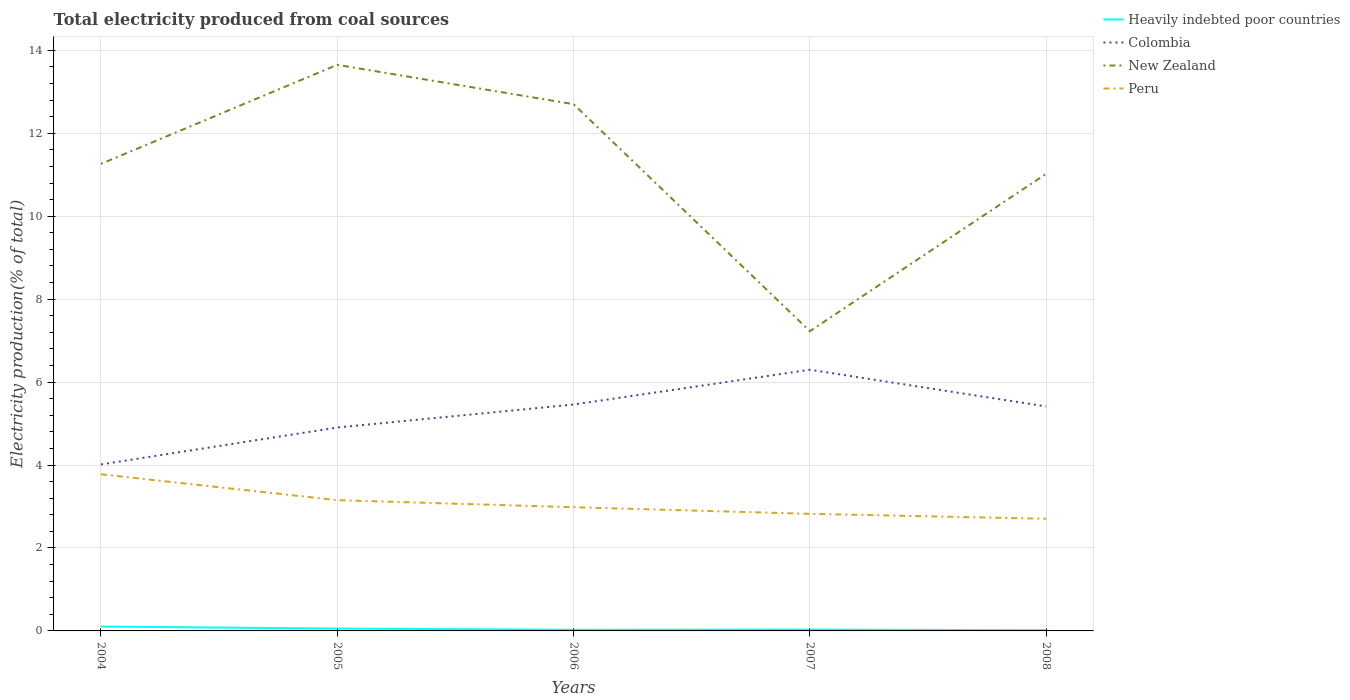Is the number of lines equal to the number of legend labels?
Offer a very short reply. Yes. Across all years, what is the maximum total electricity produced in Heavily indebted poor countries?
Keep it short and to the point. 0.02. What is the total total electricity produced in New Zealand in the graph?
Your answer should be very brief. -3.79. What is the difference between the highest and the second highest total electricity produced in Peru?
Keep it short and to the point. 1.07. Is the total electricity produced in Heavily indebted poor countries strictly greater than the total electricity produced in Colombia over the years?
Ensure brevity in your answer.  Yes. How many lines are there?
Your response must be concise. 4. Are the values on the major ticks of Y-axis written in scientific E-notation?
Your answer should be compact. No. Does the graph contain grids?
Provide a succinct answer. Yes. How many legend labels are there?
Keep it short and to the point. 4. What is the title of the graph?
Ensure brevity in your answer.  Total electricity produced from coal sources. What is the label or title of the X-axis?
Provide a succinct answer. Years. What is the Electricity production(% of total) in Heavily indebted poor countries in 2004?
Your answer should be compact. 0.11. What is the Electricity production(% of total) of Colombia in 2004?
Provide a succinct answer. 4.01. What is the Electricity production(% of total) in New Zealand in 2004?
Provide a succinct answer. 11.26. What is the Electricity production(% of total) of Peru in 2004?
Keep it short and to the point. 3.78. What is the Electricity production(% of total) in Heavily indebted poor countries in 2005?
Ensure brevity in your answer.  0.06. What is the Electricity production(% of total) of Colombia in 2005?
Your answer should be compact. 4.9. What is the Electricity production(% of total) in New Zealand in 2005?
Offer a very short reply. 13.65. What is the Electricity production(% of total) of Peru in 2005?
Provide a short and direct response. 3.15. What is the Electricity production(% of total) in Heavily indebted poor countries in 2006?
Your answer should be very brief. 0.03. What is the Electricity production(% of total) in Colombia in 2006?
Offer a terse response. 5.46. What is the Electricity production(% of total) of New Zealand in 2006?
Make the answer very short. 12.7. What is the Electricity production(% of total) in Peru in 2006?
Offer a terse response. 2.98. What is the Electricity production(% of total) in Heavily indebted poor countries in 2007?
Your answer should be compact. 0.03. What is the Electricity production(% of total) of Colombia in 2007?
Provide a short and direct response. 6.3. What is the Electricity production(% of total) in New Zealand in 2007?
Your answer should be very brief. 7.23. What is the Electricity production(% of total) in Peru in 2007?
Make the answer very short. 2.82. What is the Electricity production(% of total) in Heavily indebted poor countries in 2008?
Offer a very short reply. 0.02. What is the Electricity production(% of total) in Colombia in 2008?
Your answer should be compact. 5.41. What is the Electricity production(% of total) of New Zealand in 2008?
Keep it short and to the point. 11.02. What is the Electricity production(% of total) in Peru in 2008?
Make the answer very short. 2.7. Across all years, what is the maximum Electricity production(% of total) of Heavily indebted poor countries?
Provide a succinct answer. 0.11. Across all years, what is the maximum Electricity production(% of total) in Colombia?
Offer a very short reply. 6.3. Across all years, what is the maximum Electricity production(% of total) of New Zealand?
Keep it short and to the point. 13.65. Across all years, what is the maximum Electricity production(% of total) in Peru?
Provide a succinct answer. 3.78. Across all years, what is the minimum Electricity production(% of total) in Heavily indebted poor countries?
Make the answer very short. 0.02. Across all years, what is the minimum Electricity production(% of total) of Colombia?
Provide a short and direct response. 4.01. Across all years, what is the minimum Electricity production(% of total) of New Zealand?
Offer a terse response. 7.23. Across all years, what is the minimum Electricity production(% of total) in Peru?
Offer a very short reply. 2.7. What is the total Electricity production(% of total) of Heavily indebted poor countries in the graph?
Keep it short and to the point. 0.24. What is the total Electricity production(% of total) of Colombia in the graph?
Your answer should be compact. 26.09. What is the total Electricity production(% of total) of New Zealand in the graph?
Provide a succinct answer. 55.86. What is the total Electricity production(% of total) of Peru in the graph?
Provide a succinct answer. 15.44. What is the difference between the Electricity production(% of total) of Heavily indebted poor countries in 2004 and that in 2005?
Give a very brief answer. 0.05. What is the difference between the Electricity production(% of total) of Colombia in 2004 and that in 2005?
Give a very brief answer. -0.89. What is the difference between the Electricity production(% of total) of New Zealand in 2004 and that in 2005?
Provide a succinct answer. -2.39. What is the difference between the Electricity production(% of total) in Peru in 2004 and that in 2005?
Keep it short and to the point. 0.62. What is the difference between the Electricity production(% of total) in Heavily indebted poor countries in 2004 and that in 2006?
Your answer should be very brief. 0.08. What is the difference between the Electricity production(% of total) in Colombia in 2004 and that in 2006?
Provide a succinct answer. -1.44. What is the difference between the Electricity production(% of total) in New Zealand in 2004 and that in 2006?
Your answer should be very brief. -1.44. What is the difference between the Electricity production(% of total) in Peru in 2004 and that in 2006?
Provide a short and direct response. 0.79. What is the difference between the Electricity production(% of total) in Heavily indebted poor countries in 2004 and that in 2007?
Your response must be concise. 0.07. What is the difference between the Electricity production(% of total) in Colombia in 2004 and that in 2007?
Your answer should be very brief. -2.28. What is the difference between the Electricity production(% of total) of New Zealand in 2004 and that in 2007?
Provide a succinct answer. 4.03. What is the difference between the Electricity production(% of total) in Peru in 2004 and that in 2007?
Give a very brief answer. 0.95. What is the difference between the Electricity production(% of total) of Heavily indebted poor countries in 2004 and that in 2008?
Offer a terse response. 0.09. What is the difference between the Electricity production(% of total) of Colombia in 2004 and that in 2008?
Your response must be concise. -1.4. What is the difference between the Electricity production(% of total) in New Zealand in 2004 and that in 2008?
Ensure brevity in your answer.  0.24. What is the difference between the Electricity production(% of total) of Peru in 2004 and that in 2008?
Your answer should be very brief. 1.07. What is the difference between the Electricity production(% of total) of Heavily indebted poor countries in 2005 and that in 2006?
Your answer should be compact. 0.03. What is the difference between the Electricity production(% of total) in Colombia in 2005 and that in 2006?
Your answer should be very brief. -0.55. What is the difference between the Electricity production(% of total) in New Zealand in 2005 and that in 2006?
Keep it short and to the point. 0.95. What is the difference between the Electricity production(% of total) of Peru in 2005 and that in 2006?
Make the answer very short. 0.17. What is the difference between the Electricity production(% of total) of Heavily indebted poor countries in 2005 and that in 2007?
Provide a succinct answer. 0.02. What is the difference between the Electricity production(% of total) in Colombia in 2005 and that in 2007?
Your response must be concise. -1.39. What is the difference between the Electricity production(% of total) of New Zealand in 2005 and that in 2007?
Offer a very short reply. 6.42. What is the difference between the Electricity production(% of total) in Peru in 2005 and that in 2007?
Offer a very short reply. 0.33. What is the difference between the Electricity production(% of total) in Heavily indebted poor countries in 2005 and that in 2008?
Provide a succinct answer. 0.04. What is the difference between the Electricity production(% of total) in Colombia in 2005 and that in 2008?
Give a very brief answer. -0.51. What is the difference between the Electricity production(% of total) of New Zealand in 2005 and that in 2008?
Ensure brevity in your answer.  2.63. What is the difference between the Electricity production(% of total) in Peru in 2005 and that in 2008?
Your answer should be compact. 0.45. What is the difference between the Electricity production(% of total) in Heavily indebted poor countries in 2006 and that in 2007?
Give a very brief answer. -0. What is the difference between the Electricity production(% of total) in Colombia in 2006 and that in 2007?
Ensure brevity in your answer.  -0.84. What is the difference between the Electricity production(% of total) in New Zealand in 2006 and that in 2007?
Your answer should be compact. 5.47. What is the difference between the Electricity production(% of total) of Peru in 2006 and that in 2007?
Your response must be concise. 0.16. What is the difference between the Electricity production(% of total) of Heavily indebted poor countries in 2006 and that in 2008?
Provide a succinct answer. 0.01. What is the difference between the Electricity production(% of total) in Colombia in 2006 and that in 2008?
Give a very brief answer. 0.05. What is the difference between the Electricity production(% of total) in New Zealand in 2006 and that in 2008?
Offer a terse response. 1.68. What is the difference between the Electricity production(% of total) of Peru in 2006 and that in 2008?
Provide a succinct answer. 0.28. What is the difference between the Electricity production(% of total) in Heavily indebted poor countries in 2007 and that in 2008?
Make the answer very short. 0.02. What is the difference between the Electricity production(% of total) in Colombia in 2007 and that in 2008?
Offer a very short reply. 0.88. What is the difference between the Electricity production(% of total) of New Zealand in 2007 and that in 2008?
Your answer should be very brief. -3.79. What is the difference between the Electricity production(% of total) of Peru in 2007 and that in 2008?
Keep it short and to the point. 0.12. What is the difference between the Electricity production(% of total) in Heavily indebted poor countries in 2004 and the Electricity production(% of total) in Colombia in 2005?
Offer a very short reply. -4.8. What is the difference between the Electricity production(% of total) of Heavily indebted poor countries in 2004 and the Electricity production(% of total) of New Zealand in 2005?
Give a very brief answer. -13.54. What is the difference between the Electricity production(% of total) in Heavily indebted poor countries in 2004 and the Electricity production(% of total) in Peru in 2005?
Offer a terse response. -3.05. What is the difference between the Electricity production(% of total) of Colombia in 2004 and the Electricity production(% of total) of New Zealand in 2005?
Your answer should be very brief. -9.64. What is the difference between the Electricity production(% of total) in Colombia in 2004 and the Electricity production(% of total) in Peru in 2005?
Ensure brevity in your answer.  0.86. What is the difference between the Electricity production(% of total) of New Zealand in 2004 and the Electricity production(% of total) of Peru in 2005?
Give a very brief answer. 8.11. What is the difference between the Electricity production(% of total) in Heavily indebted poor countries in 2004 and the Electricity production(% of total) in Colombia in 2006?
Make the answer very short. -5.35. What is the difference between the Electricity production(% of total) in Heavily indebted poor countries in 2004 and the Electricity production(% of total) in New Zealand in 2006?
Offer a terse response. -12.6. What is the difference between the Electricity production(% of total) in Heavily indebted poor countries in 2004 and the Electricity production(% of total) in Peru in 2006?
Offer a terse response. -2.88. What is the difference between the Electricity production(% of total) of Colombia in 2004 and the Electricity production(% of total) of New Zealand in 2006?
Provide a short and direct response. -8.69. What is the difference between the Electricity production(% of total) in Colombia in 2004 and the Electricity production(% of total) in Peru in 2006?
Provide a succinct answer. 1.03. What is the difference between the Electricity production(% of total) in New Zealand in 2004 and the Electricity production(% of total) in Peru in 2006?
Offer a terse response. 8.28. What is the difference between the Electricity production(% of total) of Heavily indebted poor countries in 2004 and the Electricity production(% of total) of Colombia in 2007?
Your answer should be very brief. -6.19. What is the difference between the Electricity production(% of total) of Heavily indebted poor countries in 2004 and the Electricity production(% of total) of New Zealand in 2007?
Your response must be concise. -7.12. What is the difference between the Electricity production(% of total) in Heavily indebted poor countries in 2004 and the Electricity production(% of total) in Peru in 2007?
Make the answer very short. -2.72. What is the difference between the Electricity production(% of total) in Colombia in 2004 and the Electricity production(% of total) in New Zealand in 2007?
Give a very brief answer. -3.21. What is the difference between the Electricity production(% of total) in Colombia in 2004 and the Electricity production(% of total) in Peru in 2007?
Make the answer very short. 1.19. What is the difference between the Electricity production(% of total) of New Zealand in 2004 and the Electricity production(% of total) of Peru in 2007?
Ensure brevity in your answer.  8.44. What is the difference between the Electricity production(% of total) in Heavily indebted poor countries in 2004 and the Electricity production(% of total) in Colombia in 2008?
Make the answer very short. -5.31. What is the difference between the Electricity production(% of total) of Heavily indebted poor countries in 2004 and the Electricity production(% of total) of New Zealand in 2008?
Your answer should be compact. -10.92. What is the difference between the Electricity production(% of total) of Heavily indebted poor countries in 2004 and the Electricity production(% of total) of Peru in 2008?
Offer a terse response. -2.6. What is the difference between the Electricity production(% of total) in Colombia in 2004 and the Electricity production(% of total) in New Zealand in 2008?
Make the answer very short. -7.01. What is the difference between the Electricity production(% of total) of Colombia in 2004 and the Electricity production(% of total) of Peru in 2008?
Offer a terse response. 1.31. What is the difference between the Electricity production(% of total) of New Zealand in 2004 and the Electricity production(% of total) of Peru in 2008?
Your answer should be compact. 8.56. What is the difference between the Electricity production(% of total) of Heavily indebted poor countries in 2005 and the Electricity production(% of total) of Colombia in 2006?
Keep it short and to the point. -5.4. What is the difference between the Electricity production(% of total) of Heavily indebted poor countries in 2005 and the Electricity production(% of total) of New Zealand in 2006?
Make the answer very short. -12.64. What is the difference between the Electricity production(% of total) of Heavily indebted poor countries in 2005 and the Electricity production(% of total) of Peru in 2006?
Your response must be concise. -2.93. What is the difference between the Electricity production(% of total) in Colombia in 2005 and the Electricity production(% of total) in New Zealand in 2006?
Provide a short and direct response. -7.8. What is the difference between the Electricity production(% of total) in Colombia in 2005 and the Electricity production(% of total) in Peru in 2006?
Your response must be concise. 1.92. What is the difference between the Electricity production(% of total) in New Zealand in 2005 and the Electricity production(% of total) in Peru in 2006?
Offer a terse response. 10.67. What is the difference between the Electricity production(% of total) in Heavily indebted poor countries in 2005 and the Electricity production(% of total) in Colombia in 2007?
Give a very brief answer. -6.24. What is the difference between the Electricity production(% of total) of Heavily indebted poor countries in 2005 and the Electricity production(% of total) of New Zealand in 2007?
Provide a succinct answer. -7.17. What is the difference between the Electricity production(% of total) of Heavily indebted poor countries in 2005 and the Electricity production(% of total) of Peru in 2007?
Make the answer very short. -2.77. What is the difference between the Electricity production(% of total) in Colombia in 2005 and the Electricity production(% of total) in New Zealand in 2007?
Your answer should be compact. -2.32. What is the difference between the Electricity production(% of total) of Colombia in 2005 and the Electricity production(% of total) of Peru in 2007?
Your response must be concise. 2.08. What is the difference between the Electricity production(% of total) of New Zealand in 2005 and the Electricity production(% of total) of Peru in 2007?
Your answer should be compact. 10.83. What is the difference between the Electricity production(% of total) in Heavily indebted poor countries in 2005 and the Electricity production(% of total) in Colombia in 2008?
Provide a short and direct response. -5.36. What is the difference between the Electricity production(% of total) in Heavily indebted poor countries in 2005 and the Electricity production(% of total) in New Zealand in 2008?
Offer a terse response. -10.97. What is the difference between the Electricity production(% of total) in Heavily indebted poor countries in 2005 and the Electricity production(% of total) in Peru in 2008?
Your answer should be very brief. -2.65. What is the difference between the Electricity production(% of total) of Colombia in 2005 and the Electricity production(% of total) of New Zealand in 2008?
Give a very brief answer. -6.12. What is the difference between the Electricity production(% of total) of Colombia in 2005 and the Electricity production(% of total) of Peru in 2008?
Offer a terse response. 2.2. What is the difference between the Electricity production(% of total) in New Zealand in 2005 and the Electricity production(% of total) in Peru in 2008?
Provide a short and direct response. 10.95. What is the difference between the Electricity production(% of total) in Heavily indebted poor countries in 2006 and the Electricity production(% of total) in Colombia in 2007?
Give a very brief answer. -6.27. What is the difference between the Electricity production(% of total) of Heavily indebted poor countries in 2006 and the Electricity production(% of total) of New Zealand in 2007?
Your response must be concise. -7.2. What is the difference between the Electricity production(% of total) of Heavily indebted poor countries in 2006 and the Electricity production(% of total) of Peru in 2007?
Ensure brevity in your answer.  -2.8. What is the difference between the Electricity production(% of total) of Colombia in 2006 and the Electricity production(% of total) of New Zealand in 2007?
Your answer should be compact. -1.77. What is the difference between the Electricity production(% of total) of Colombia in 2006 and the Electricity production(% of total) of Peru in 2007?
Offer a very short reply. 2.64. What is the difference between the Electricity production(% of total) of New Zealand in 2006 and the Electricity production(% of total) of Peru in 2007?
Provide a short and direct response. 9.88. What is the difference between the Electricity production(% of total) in Heavily indebted poor countries in 2006 and the Electricity production(% of total) in Colombia in 2008?
Offer a very short reply. -5.39. What is the difference between the Electricity production(% of total) of Heavily indebted poor countries in 2006 and the Electricity production(% of total) of New Zealand in 2008?
Ensure brevity in your answer.  -10.99. What is the difference between the Electricity production(% of total) in Heavily indebted poor countries in 2006 and the Electricity production(% of total) in Peru in 2008?
Provide a short and direct response. -2.68. What is the difference between the Electricity production(% of total) of Colombia in 2006 and the Electricity production(% of total) of New Zealand in 2008?
Provide a succinct answer. -5.56. What is the difference between the Electricity production(% of total) in Colombia in 2006 and the Electricity production(% of total) in Peru in 2008?
Provide a short and direct response. 2.75. What is the difference between the Electricity production(% of total) in New Zealand in 2006 and the Electricity production(% of total) in Peru in 2008?
Offer a very short reply. 10. What is the difference between the Electricity production(% of total) of Heavily indebted poor countries in 2007 and the Electricity production(% of total) of Colombia in 2008?
Provide a short and direct response. -5.38. What is the difference between the Electricity production(% of total) in Heavily indebted poor countries in 2007 and the Electricity production(% of total) in New Zealand in 2008?
Provide a succinct answer. -10.99. What is the difference between the Electricity production(% of total) of Heavily indebted poor countries in 2007 and the Electricity production(% of total) of Peru in 2008?
Your answer should be very brief. -2.67. What is the difference between the Electricity production(% of total) in Colombia in 2007 and the Electricity production(% of total) in New Zealand in 2008?
Your response must be concise. -4.72. What is the difference between the Electricity production(% of total) in Colombia in 2007 and the Electricity production(% of total) in Peru in 2008?
Give a very brief answer. 3.59. What is the difference between the Electricity production(% of total) of New Zealand in 2007 and the Electricity production(% of total) of Peru in 2008?
Offer a terse response. 4.52. What is the average Electricity production(% of total) of Heavily indebted poor countries per year?
Your answer should be compact. 0.05. What is the average Electricity production(% of total) in Colombia per year?
Provide a short and direct response. 5.22. What is the average Electricity production(% of total) of New Zealand per year?
Make the answer very short. 11.17. What is the average Electricity production(% of total) in Peru per year?
Offer a very short reply. 3.09. In the year 2004, what is the difference between the Electricity production(% of total) in Heavily indebted poor countries and Electricity production(% of total) in Colombia?
Your response must be concise. -3.91. In the year 2004, what is the difference between the Electricity production(% of total) in Heavily indebted poor countries and Electricity production(% of total) in New Zealand?
Your response must be concise. -11.16. In the year 2004, what is the difference between the Electricity production(% of total) in Heavily indebted poor countries and Electricity production(% of total) in Peru?
Make the answer very short. -3.67. In the year 2004, what is the difference between the Electricity production(% of total) in Colombia and Electricity production(% of total) in New Zealand?
Provide a short and direct response. -7.25. In the year 2004, what is the difference between the Electricity production(% of total) in Colombia and Electricity production(% of total) in Peru?
Make the answer very short. 0.24. In the year 2004, what is the difference between the Electricity production(% of total) of New Zealand and Electricity production(% of total) of Peru?
Give a very brief answer. 7.49. In the year 2005, what is the difference between the Electricity production(% of total) of Heavily indebted poor countries and Electricity production(% of total) of Colombia?
Give a very brief answer. -4.85. In the year 2005, what is the difference between the Electricity production(% of total) of Heavily indebted poor countries and Electricity production(% of total) of New Zealand?
Ensure brevity in your answer.  -13.59. In the year 2005, what is the difference between the Electricity production(% of total) of Heavily indebted poor countries and Electricity production(% of total) of Peru?
Your answer should be compact. -3.1. In the year 2005, what is the difference between the Electricity production(% of total) in Colombia and Electricity production(% of total) in New Zealand?
Your response must be concise. -8.74. In the year 2005, what is the difference between the Electricity production(% of total) of Colombia and Electricity production(% of total) of Peru?
Provide a succinct answer. 1.75. In the year 2005, what is the difference between the Electricity production(% of total) in New Zealand and Electricity production(% of total) in Peru?
Your response must be concise. 10.5. In the year 2006, what is the difference between the Electricity production(% of total) in Heavily indebted poor countries and Electricity production(% of total) in Colombia?
Ensure brevity in your answer.  -5.43. In the year 2006, what is the difference between the Electricity production(% of total) of Heavily indebted poor countries and Electricity production(% of total) of New Zealand?
Ensure brevity in your answer.  -12.67. In the year 2006, what is the difference between the Electricity production(% of total) of Heavily indebted poor countries and Electricity production(% of total) of Peru?
Your answer should be compact. -2.95. In the year 2006, what is the difference between the Electricity production(% of total) of Colombia and Electricity production(% of total) of New Zealand?
Offer a terse response. -7.24. In the year 2006, what is the difference between the Electricity production(% of total) of Colombia and Electricity production(% of total) of Peru?
Your answer should be very brief. 2.48. In the year 2006, what is the difference between the Electricity production(% of total) in New Zealand and Electricity production(% of total) in Peru?
Offer a terse response. 9.72. In the year 2007, what is the difference between the Electricity production(% of total) in Heavily indebted poor countries and Electricity production(% of total) in Colombia?
Give a very brief answer. -6.27. In the year 2007, what is the difference between the Electricity production(% of total) of Heavily indebted poor countries and Electricity production(% of total) of New Zealand?
Your answer should be very brief. -7.2. In the year 2007, what is the difference between the Electricity production(% of total) in Heavily indebted poor countries and Electricity production(% of total) in Peru?
Your answer should be compact. -2.79. In the year 2007, what is the difference between the Electricity production(% of total) of Colombia and Electricity production(% of total) of New Zealand?
Your answer should be compact. -0.93. In the year 2007, what is the difference between the Electricity production(% of total) of Colombia and Electricity production(% of total) of Peru?
Give a very brief answer. 3.47. In the year 2007, what is the difference between the Electricity production(% of total) of New Zealand and Electricity production(% of total) of Peru?
Offer a very short reply. 4.4. In the year 2008, what is the difference between the Electricity production(% of total) in Heavily indebted poor countries and Electricity production(% of total) in Colombia?
Keep it short and to the point. -5.4. In the year 2008, what is the difference between the Electricity production(% of total) in Heavily indebted poor countries and Electricity production(% of total) in New Zealand?
Give a very brief answer. -11.01. In the year 2008, what is the difference between the Electricity production(% of total) of Heavily indebted poor countries and Electricity production(% of total) of Peru?
Provide a short and direct response. -2.69. In the year 2008, what is the difference between the Electricity production(% of total) of Colombia and Electricity production(% of total) of New Zealand?
Ensure brevity in your answer.  -5.61. In the year 2008, what is the difference between the Electricity production(% of total) of Colombia and Electricity production(% of total) of Peru?
Keep it short and to the point. 2.71. In the year 2008, what is the difference between the Electricity production(% of total) of New Zealand and Electricity production(% of total) of Peru?
Make the answer very short. 8.32. What is the ratio of the Electricity production(% of total) in Heavily indebted poor countries in 2004 to that in 2005?
Give a very brief answer. 1.86. What is the ratio of the Electricity production(% of total) of Colombia in 2004 to that in 2005?
Provide a short and direct response. 0.82. What is the ratio of the Electricity production(% of total) of New Zealand in 2004 to that in 2005?
Ensure brevity in your answer.  0.83. What is the ratio of the Electricity production(% of total) of Peru in 2004 to that in 2005?
Your answer should be compact. 1.2. What is the ratio of the Electricity production(% of total) of Heavily indebted poor countries in 2004 to that in 2006?
Offer a terse response. 3.75. What is the ratio of the Electricity production(% of total) of Colombia in 2004 to that in 2006?
Provide a short and direct response. 0.74. What is the ratio of the Electricity production(% of total) in New Zealand in 2004 to that in 2006?
Your response must be concise. 0.89. What is the ratio of the Electricity production(% of total) of Peru in 2004 to that in 2006?
Keep it short and to the point. 1.27. What is the ratio of the Electricity production(% of total) in Heavily indebted poor countries in 2004 to that in 2007?
Your answer should be compact. 3.25. What is the ratio of the Electricity production(% of total) in Colombia in 2004 to that in 2007?
Provide a short and direct response. 0.64. What is the ratio of the Electricity production(% of total) of New Zealand in 2004 to that in 2007?
Ensure brevity in your answer.  1.56. What is the ratio of the Electricity production(% of total) of Peru in 2004 to that in 2007?
Your answer should be compact. 1.34. What is the ratio of the Electricity production(% of total) of Heavily indebted poor countries in 2004 to that in 2008?
Offer a terse response. 6.16. What is the ratio of the Electricity production(% of total) of Colombia in 2004 to that in 2008?
Provide a succinct answer. 0.74. What is the ratio of the Electricity production(% of total) of New Zealand in 2004 to that in 2008?
Offer a very short reply. 1.02. What is the ratio of the Electricity production(% of total) in Peru in 2004 to that in 2008?
Ensure brevity in your answer.  1.4. What is the ratio of the Electricity production(% of total) in Heavily indebted poor countries in 2005 to that in 2006?
Offer a terse response. 2.02. What is the ratio of the Electricity production(% of total) in Colombia in 2005 to that in 2006?
Make the answer very short. 0.9. What is the ratio of the Electricity production(% of total) in New Zealand in 2005 to that in 2006?
Offer a terse response. 1.07. What is the ratio of the Electricity production(% of total) of Peru in 2005 to that in 2006?
Offer a very short reply. 1.06. What is the ratio of the Electricity production(% of total) of Heavily indebted poor countries in 2005 to that in 2007?
Provide a succinct answer. 1.75. What is the ratio of the Electricity production(% of total) of Colombia in 2005 to that in 2007?
Give a very brief answer. 0.78. What is the ratio of the Electricity production(% of total) of New Zealand in 2005 to that in 2007?
Give a very brief answer. 1.89. What is the ratio of the Electricity production(% of total) in Peru in 2005 to that in 2007?
Your answer should be compact. 1.12. What is the ratio of the Electricity production(% of total) in Heavily indebted poor countries in 2005 to that in 2008?
Ensure brevity in your answer.  3.31. What is the ratio of the Electricity production(% of total) in Colombia in 2005 to that in 2008?
Offer a very short reply. 0.91. What is the ratio of the Electricity production(% of total) of New Zealand in 2005 to that in 2008?
Give a very brief answer. 1.24. What is the ratio of the Electricity production(% of total) of Peru in 2005 to that in 2008?
Your answer should be very brief. 1.17. What is the ratio of the Electricity production(% of total) in Heavily indebted poor countries in 2006 to that in 2007?
Give a very brief answer. 0.87. What is the ratio of the Electricity production(% of total) of Colombia in 2006 to that in 2007?
Ensure brevity in your answer.  0.87. What is the ratio of the Electricity production(% of total) in New Zealand in 2006 to that in 2007?
Provide a succinct answer. 1.76. What is the ratio of the Electricity production(% of total) of Peru in 2006 to that in 2007?
Offer a very short reply. 1.06. What is the ratio of the Electricity production(% of total) of Heavily indebted poor countries in 2006 to that in 2008?
Offer a very short reply. 1.64. What is the ratio of the Electricity production(% of total) in Colombia in 2006 to that in 2008?
Offer a terse response. 1.01. What is the ratio of the Electricity production(% of total) of New Zealand in 2006 to that in 2008?
Give a very brief answer. 1.15. What is the ratio of the Electricity production(% of total) in Peru in 2006 to that in 2008?
Your answer should be compact. 1.1. What is the ratio of the Electricity production(% of total) of Heavily indebted poor countries in 2007 to that in 2008?
Provide a short and direct response. 1.9. What is the ratio of the Electricity production(% of total) in Colombia in 2007 to that in 2008?
Provide a short and direct response. 1.16. What is the ratio of the Electricity production(% of total) of New Zealand in 2007 to that in 2008?
Give a very brief answer. 0.66. What is the ratio of the Electricity production(% of total) in Peru in 2007 to that in 2008?
Give a very brief answer. 1.04. What is the difference between the highest and the second highest Electricity production(% of total) in Heavily indebted poor countries?
Offer a very short reply. 0.05. What is the difference between the highest and the second highest Electricity production(% of total) in Colombia?
Offer a very short reply. 0.84. What is the difference between the highest and the second highest Electricity production(% of total) of New Zealand?
Your answer should be very brief. 0.95. What is the difference between the highest and the second highest Electricity production(% of total) of Peru?
Offer a terse response. 0.62. What is the difference between the highest and the lowest Electricity production(% of total) in Heavily indebted poor countries?
Offer a very short reply. 0.09. What is the difference between the highest and the lowest Electricity production(% of total) of Colombia?
Offer a terse response. 2.28. What is the difference between the highest and the lowest Electricity production(% of total) in New Zealand?
Give a very brief answer. 6.42. What is the difference between the highest and the lowest Electricity production(% of total) of Peru?
Offer a terse response. 1.07. 